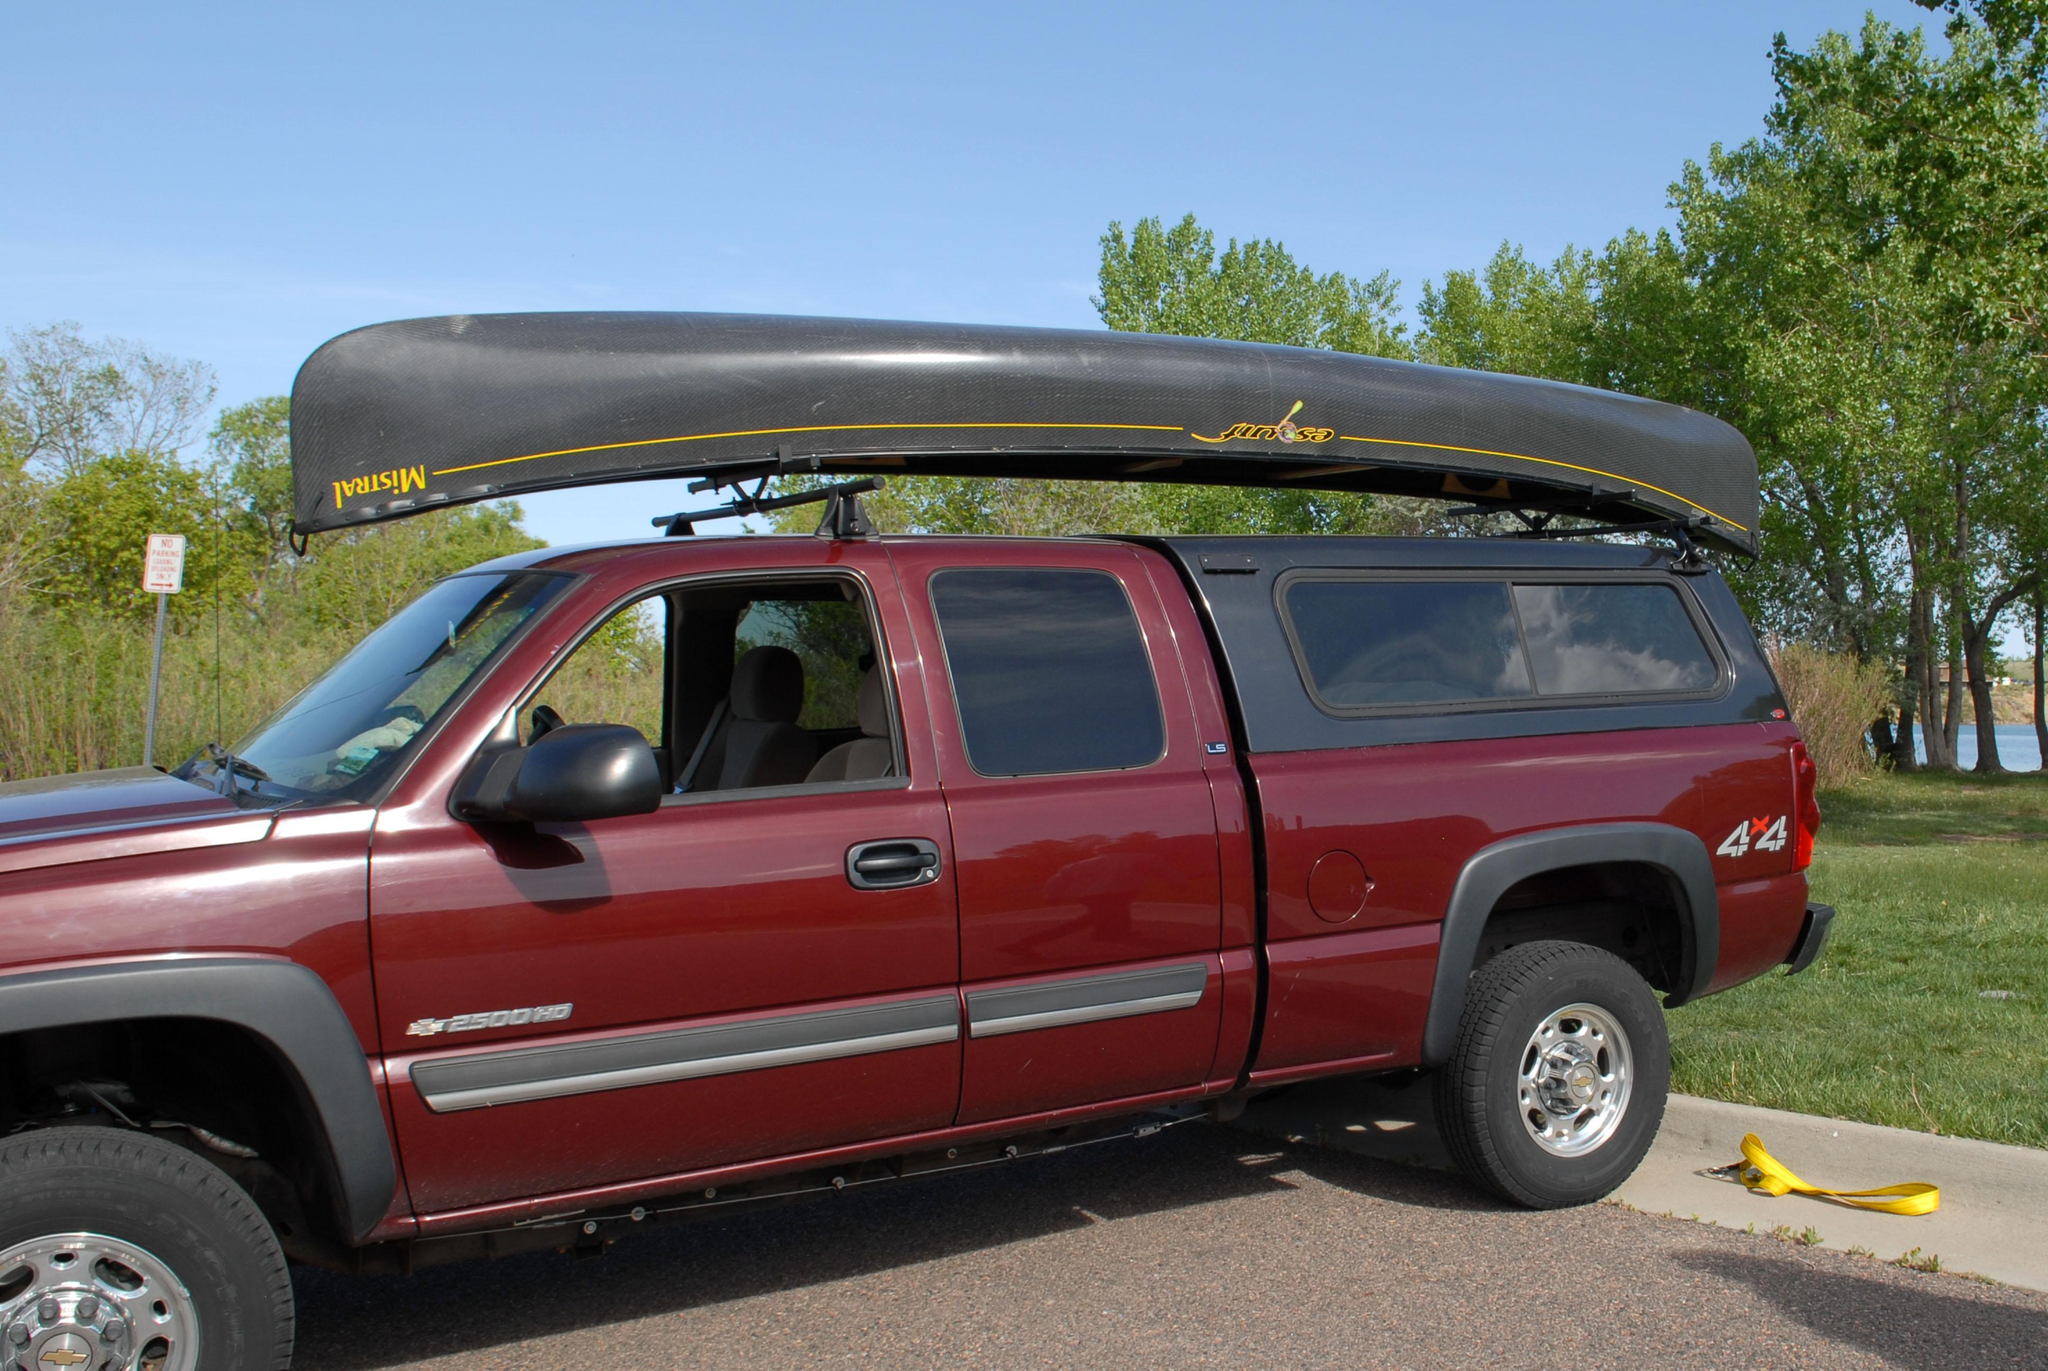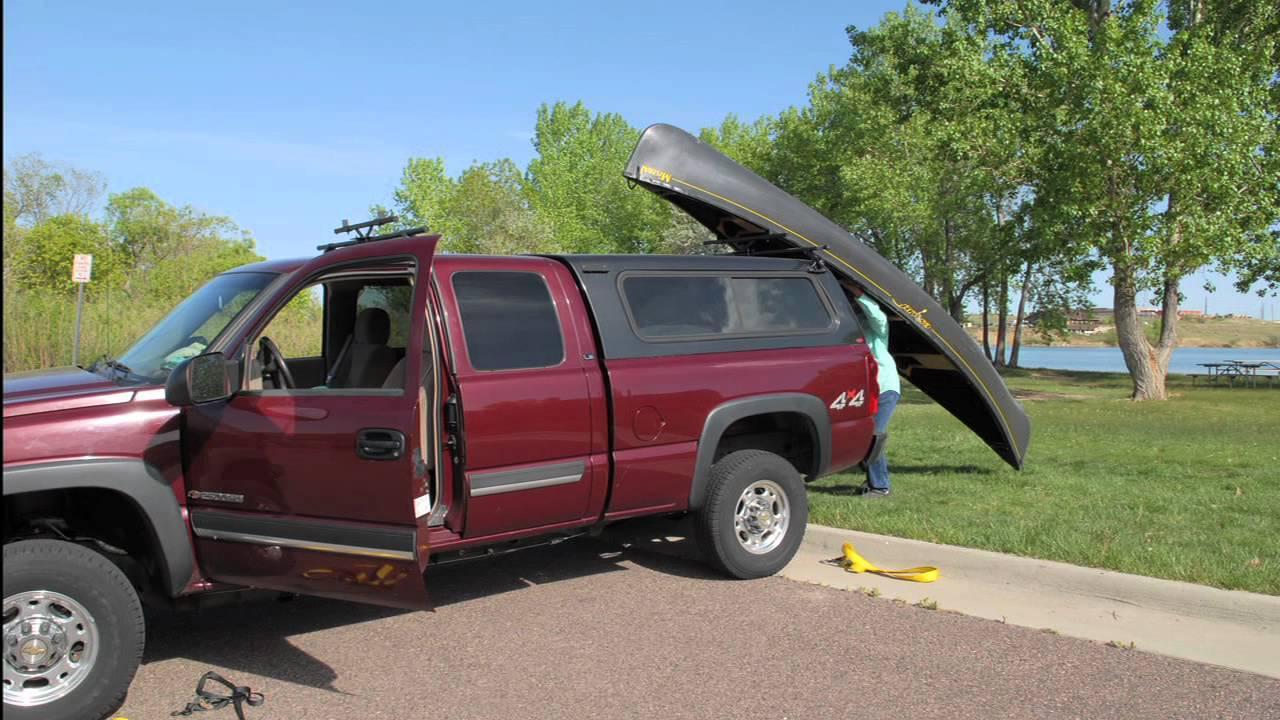The first image is the image on the left, the second image is the image on the right. Given the left and right images, does the statement "A dark green canoe is on top of an open-bed pickup truck." hold true? Answer yes or no. No. 